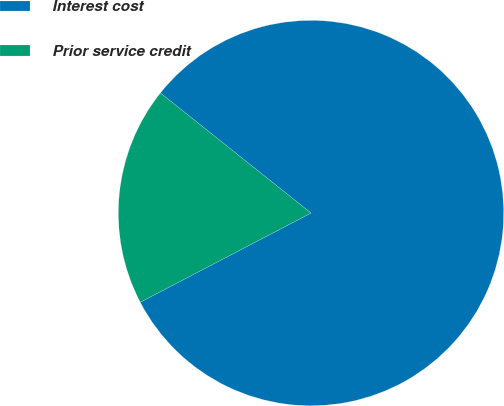Convert chart. <chart><loc_0><loc_0><loc_500><loc_500><pie_chart><fcel>Interest cost<fcel>Prior service credit<nl><fcel>81.63%<fcel>18.37%<nl></chart> 